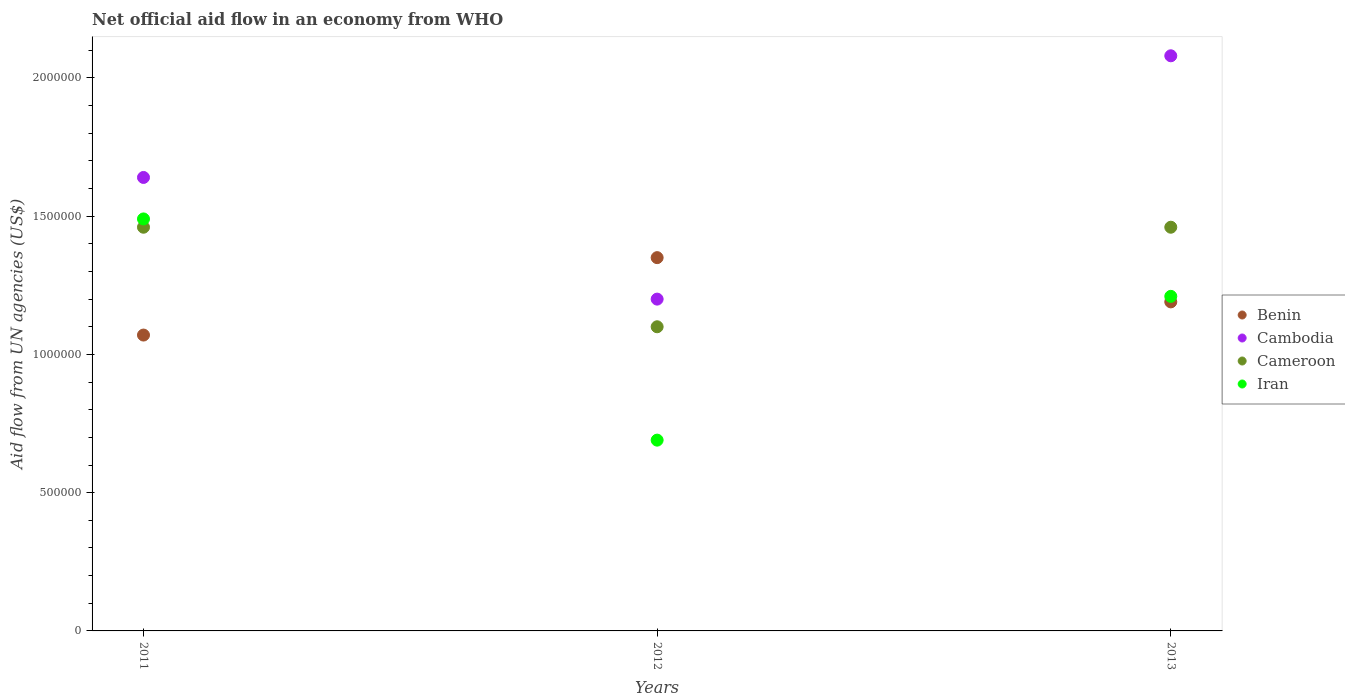How many different coloured dotlines are there?
Provide a succinct answer. 4. What is the net official aid flow in Cambodia in 2012?
Your response must be concise. 1.20e+06. Across all years, what is the maximum net official aid flow in Benin?
Keep it short and to the point. 1.35e+06. Across all years, what is the minimum net official aid flow in Benin?
Your answer should be compact. 1.07e+06. What is the total net official aid flow in Cambodia in the graph?
Your answer should be compact. 4.92e+06. What is the difference between the net official aid flow in Benin in 2011 and that in 2012?
Offer a very short reply. -2.80e+05. What is the difference between the net official aid flow in Cambodia in 2013 and the net official aid flow in Cameroon in 2012?
Your answer should be very brief. 9.80e+05. What is the average net official aid flow in Benin per year?
Your answer should be compact. 1.20e+06. In the year 2012, what is the difference between the net official aid flow in Cameroon and net official aid flow in Iran?
Your answer should be very brief. 4.10e+05. What is the ratio of the net official aid flow in Iran in 2011 to that in 2012?
Give a very brief answer. 2.16. Is the net official aid flow in Iran in 2011 less than that in 2012?
Offer a terse response. No. What is the difference between the highest and the second highest net official aid flow in Cambodia?
Provide a short and direct response. 4.40e+05. What is the difference between the highest and the lowest net official aid flow in Benin?
Offer a terse response. 2.80e+05. Is the sum of the net official aid flow in Cambodia in 2012 and 2013 greater than the maximum net official aid flow in Cameroon across all years?
Make the answer very short. Yes. Is it the case that in every year, the sum of the net official aid flow in Benin and net official aid flow in Cameroon  is greater than the sum of net official aid flow in Cambodia and net official aid flow in Iran?
Offer a very short reply. Yes. Is the net official aid flow in Cambodia strictly less than the net official aid flow in Benin over the years?
Your answer should be very brief. No. How are the legend labels stacked?
Your response must be concise. Vertical. What is the title of the graph?
Your response must be concise. Net official aid flow in an economy from WHO. Does "Cameroon" appear as one of the legend labels in the graph?
Provide a succinct answer. Yes. What is the label or title of the X-axis?
Give a very brief answer. Years. What is the label or title of the Y-axis?
Your response must be concise. Aid flow from UN agencies (US$). What is the Aid flow from UN agencies (US$) of Benin in 2011?
Provide a succinct answer. 1.07e+06. What is the Aid flow from UN agencies (US$) of Cambodia in 2011?
Provide a succinct answer. 1.64e+06. What is the Aid flow from UN agencies (US$) in Cameroon in 2011?
Provide a short and direct response. 1.46e+06. What is the Aid flow from UN agencies (US$) in Iran in 2011?
Provide a short and direct response. 1.49e+06. What is the Aid flow from UN agencies (US$) in Benin in 2012?
Provide a short and direct response. 1.35e+06. What is the Aid flow from UN agencies (US$) of Cambodia in 2012?
Provide a succinct answer. 1.20e+06. What is the Aid flow from UN agencies (US$) in Cameroon in 2012?
Provide a succinct answer. 1.10e+06. What is the Aid flow from UN agencies (US$) of Iran in 2012?
Keep it short and to the point. 6.90e+05. What is the Aid flow from UN agencies (US$) of Benin in 2013?
Your answer should be compact. 1.19e+06. What is the Aid flow from UN agencies (US$) in Cambodia in 2013?
Give a very brief answer. 2.08e+06. What is the Aid flow from UN agencies (US$) in Cameroon in 2013?
Provide a short and direct response. 1.46e+06. What is the Aid flow from UN agencies (US$) of Iran in 2013?
Keep it short and to the point. 1.21e+06. Across all years, what is the maximum Aid flow from UN agencies (US$) in Benin?
Provide a short and direct response. 1.35e+06. Across all years, what is the maximum Aid flow from UN agencies (US$) of Cambodia?
Give a very brief answer. 2.08e+06. Across all years, what is the maximum Aid flow from UN agencies (US$) in Cameroon?
Your answer should be very brief. 1.46e+06. Across all years, what is the maximum Aid flow from UN agencies (US$) in Iran?
Provide a succinct answer. 1.49e+06. Across all years, what is the minimum Aid flow from UN agencies (US$) in Benin?
Your response must be concise. 1.07e+06. Across all years, what is the minimum Aid flow from UN agencies (US$) in Cambodia?
Give a very brief answer. 1.20e+06. Across all years, what is the minimum Aid flow from UN agencies (US$) in Cameroon?
Give a very brief answer. 1.10e+06. Across all years, what is the minimum Aid flow from UN agencies (US$) of Iran?
Provide a succinct answer. 6.90e+05. What is the total Aid flow from UN agencies (US$) in Benin in the graph?
Make the answer very short. 3.61e+06. What is the total Aid flow from UN agencies (US$) of Cambodia in the graph?
Offer a terse response. 4.92e+06. What is the total Aid flow from UN agencies (US$) of Cameroon in the graph?
Keep it short and to the point. 4.02e+06. What is the total Aid flow from UN agencies (US$) of Iran in the graph?
Your answer should be compact. 3.39e+06. What is the difference between the Aid flow from UN agencies (US$) of Benin in 2011 and that in 2012?
Give a very brief answer. -2.80e+05. What is the difference between the Aid flow from UN agencies (US$) in Iran in 2011 and that in 2012?
Provide a succinct answer. 8.00e+05. What is the difference between the Aid flow from UN agencies (US$) in Benin in 2011 and that in 2013?
Give a very brief answer. -1.20e+05. What is the difference between the Aid flow from UN agencies (US$) in Cambodia in 2011 and that in 2013?
Ensure brevity in your answer.  -4.40e+05. What is the difference between the Aid flow from UN agencies (US$) of Cameroon in 2011 and that in 2013?
Your answer should be very brief. 0. What is the difference between the Aid flow from UN agencies (US$) in Iran in 2011 and that in 2013?
Keep it short and to the point. 2.80e+05. What is the difference between the Aid flow from UN agencies (US$) of Cambodia in 2012 and that in 2013?
Keep it short and to the point. -8.80e+05. What is the difference between the Aid flow from UN agencies (US$) in Cameroon in 2012 and that in 2013?
Give a very brief answer. -3.60e+05. What is the difference between the Aid flow from UN agencies (US$) in Iran in 2012 and that in 2013?
Offer a terse response. -5.20e+05. What is the difference between the Aid flow from UN agencies (US$) of Benin in 2011 and the Aid flow from UN agencies (US$) of Cambodia in 2012?
Offer a terse response. -1.30e+05. What is the difference between the Aid flow from UN agencies (US$) in Benin in 2011 and the Aid flow from UN agencies (US$) in Iran in 2012?
Your answer should be very brief. 3.80e+05. What is the difference between the Aid flow from UN agencies (US$) of Cambodia in 2011 and the Aid flow from UN agencies (US$) of Cameroon in 2012?
Make the answer very short. 5.40e+05. What is the difference between the Aid flow from UN agencies (US$) in Cambodia in 2011 and the Aid flow from UN agencies (US$) in Iran in 2012?
Your answer should be compact. 9.50e+05. What is the difference between the Aid flow from UN agencies (US$) in Cameroon in 2011 and the Aid flow from UN agencies (US$) in Iran in 2012?
Provide a short and direct response. 7.70e+05. What is the difference between the Aid flow from UN agencies (US$) in Benin in 2011 and the Aid flow from UN agencies (US$) in Cambodia in 2013?
Provide a succinct answer. -1.01e+06. What is the difference between the Aid flow from UN agencies (US$) in Benin in 2011 and the Aid flow from UN agencies (US$) in Cameroon in 2013?
Provide a succinct answer. -3.90e+05. What is the difference between the Aid flow from UN agencies (US$) of Benin in 2011 and the Aid flow from UN agencies (US$) of Iran in 2013?
Ensure brevity in your answer.  -1.40e+05. What is the difference between the Aid flow from UN agencies (US$) of Cambodia in 2011 and the Aid flow from UN agencies (US$) of Iran in 2013?
Your answer should be compact. 4.30e+05. What is the difference between the Aid flow from UN agencies (US$) in Benin in 2012 and the Aid flow from UN agencies (US$) in Cambodia in 2013?
Your answer should be compact. -7.30e+05. What is the difference between the Aid flow from UN agencies (US$) in Cambodia in 2012 and the Aid flow from UN agencies (US$) in Cameroon in 2013?
Ensure brevity in your answer.  -2.60e+05. What is the average Aid flow from UN agencies (US$) of Benin per year?
Your response must be concise. 1.20e+06. What is the average Aid flow from UN agencies (US$) of Cambodia per year?
Provide a succinct answer. 1.64e+06. What is the average Aid flow from UN agencies (US$) of Cameroon per year?
Your answer should be very brief. 1.34e+06. What is the average Aid flow from UN agencies (US$) of Iran per year?
Offer a very short reply. 1.13e+06. In the year 2011, what is the difference between the Aid flow from UN agencies (US$) of Benin and Aid flow from UN agencies (US$) of Cambodia?
Offer a very short reply. -5.70e+05. In the year 2011, what is the difference between the Aid flow from UN agencies (US$) of Benin and Aid flow from UN agencies (US$) of Cameroon?
Give a very brief answer. -3.90e+05. In the year 2011, what is the difference between the Aid flow from UN agencies (US$) of Benin and Aid flow from UN agencies (US$) of Iran?
Provide a succinct answer. -4.20e+05. In the year 2012, what is the difference between the Aid flow from UN agencies (US$) in Benin and Aid flow from UN agencies (US$) in Cambodia?
Offer a terse response. 1.50e+05. In the year 2012, what is the difference between the Aid flow from UN agencies (US$) of Benin and Aid flow from UN agencies (US$) of Cameroon?
Keep it short and to the point. 2.50e+05. In the year 2012, what is the difference between the Aid flow from UN agencies (US$) of Benin and Aid flow from UN agencies (US$) of Iran?
Keep it short and to the point. 6.60e+05. In the year 2012, what is the difference between the Aid flow from UN agencies (US$) of Cambodia and Aid flow from UN agencies (US$) of Iran?
Your answer should be compact. 5.10e+05. In the year 2012, what is the difference between the Aid flow from UN agencies (US$) of Cameroon and Aid flow from UN agencies (US$) of Iran?
Make the answer very short. 4.10e+05. In the year 2013, what is the difference between the Aid flow from UN agencies (US$) of Benin and Aid flow from UN agencies (US$) of Cambodia?
Provide a short and direct response. -8.90e+05. In the year 2013, what is the difference between the Aid flow from UN agencies (US$) in Cambodia and Aid flow from UN agencies (US$) in Cameroon?
Ensure brevity in your answer.  6.20e+05. In the year 2013, what is the difference between the Aid flow from UN agencies (US$) of Cambodia and Aid flow from UN agencies (US$) of Iran?
Your response must be concise. 8.70e+05. In the year 2013, what is the difference between the Aid flow from UN agencies (US$) of Cameroon and Aid flow from UN agencies (US$) of Iran?
Give a very brief answer. 2.50e+05. What is the ratio of the Aid flow from UN agencies (US$) of Benin in 2011 to that in 2012?
Your response must be concise. 0.79. What is the ratio of the Aid flow from UN agencies (US$) of Cambodia in 2011 to that in 2012?
Offer a terse response. 1.37. What is the ratio of the Aid flow from UN agencies (US$) in Cameroon in 2011 to that in 2012?
Make the answer very short. 1.33. What is the ratio of the Aid flow from UN agencies (US$) of Iran in 2011 to that in 2012?
Your answer should be very brief. 2.16. What is the ratio of the Aid flow from UN agencies (US$) in Benin in 2011 to that in 2013?
Offer a very short reply. 0.9. What is the ratio of the Aid flow from UN agencies (US$) of Cambodia in 2011 to that in 2013?
Make the answer very short. 0.79. What is the ratio of the Aid flow from UN agencies (US$) in Iran in 2011 to that in 2013?
Your answer should be very brief. 1.23. What is the ratio of the Aid flow from UN agencies (US$) of Benin in 2012 to that in 2013?
Your answer should be very brief. 1.13. What is the ratio of the Aid flow from UN agencies (US$) of Cambodia in 2012 to that in 2013?
Make the answer very short. 0.58. What is the ratio of the Aid flow from UN agencies (US$) in Cameroon in 2012 to that in 2013?
Give a very brief answer. 0.75. What is the ratio of the Aid flow from UN agencies (US$) in Iran in 2012 to that in 2013?
Keep it short and to the point. 0.57. What is the difference between the highest and the second highest Aid flow from UN agencies (US$) of Benin?
Your response must be concise. 1.60e+05. What is the difference between the highest and the lowest Aid flow from UN agencies (US$) of Benin?
Provide a short and direct response. 2.80e+05. What is the difference between the highest and the lowest Aid flow from UN agencies (US$) of Cambodia?
Your response must be concise. 8.80e+05. What is the difference between the highest and the lowest Aid flow from UN agencies (US$) of Cameroon?
Ensure brevity in your answer.  3.60e+05. 